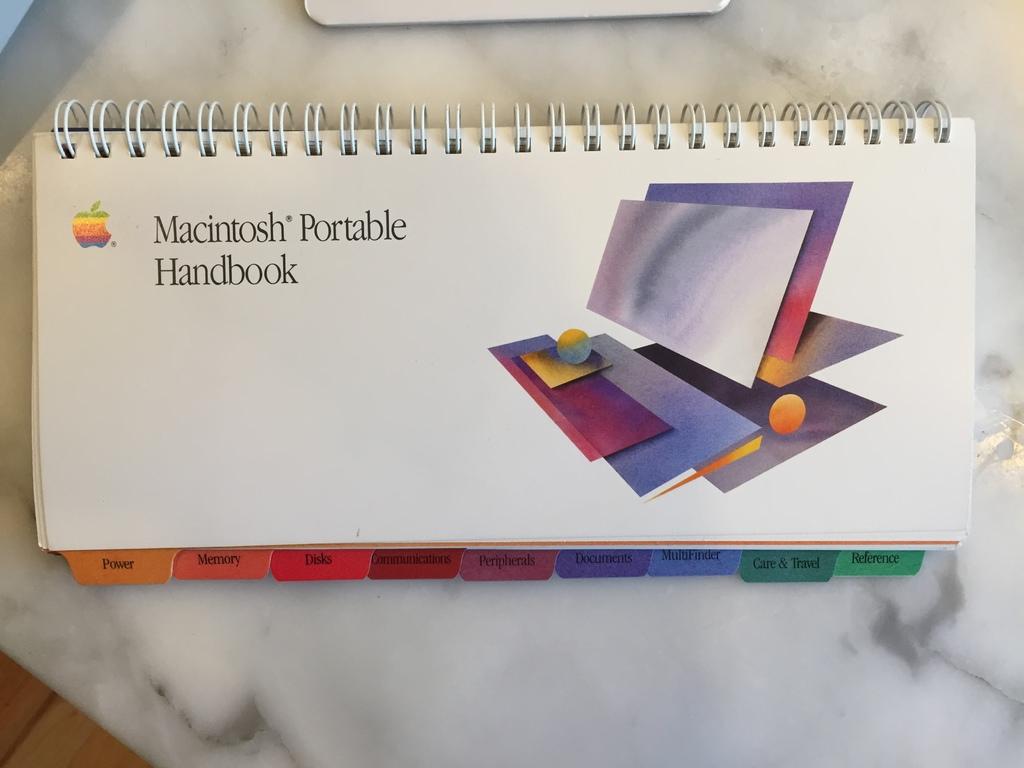What brand is featured?
Your answer should be compact. Macintosh. 